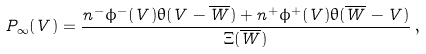<formula> <loc_0><loc_0><loc_500><loc_500>P _ { \infty } ( V ) = \frac { n ^ { - } \phi ^ { - } ( V ) \theta ( V - \overline { W } ) + n ^ { + } \phi ^ { + } ( V ) \theta ( \overline { W } - V ) } { \Xi ( \overline { W } ) } \, ,</formula> 